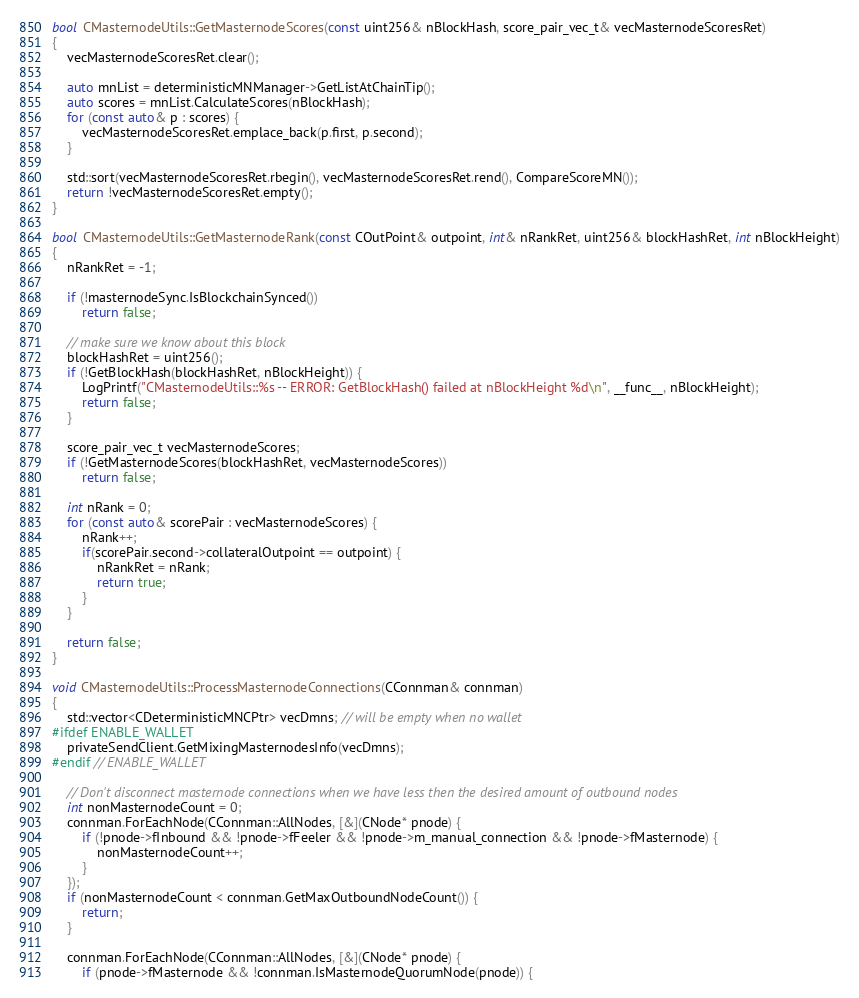Convert code to text. <code><loc_0><loc_0><loc_500><loc_500><_C++_>
bool CMasternodeUtils::GetMasternodeScores(const uint256& nBlockHash, score_pair_vec_t& vecMasternodeScoresRet)
{
    vecMasternodeScoresRet.clear();

    auto mnList = deterministicMNManager->GetListAtChainTip();
    auto scores = mnList.CalculateScores(nBlockHash);
    for (const auto& p : scores) {
        vecMasternodeScoresRet.emplace_back(p.first, p.second);
    }

    std::sort(vecMasternodeScoresRet.rbegin(), vecMasternodeScoresRet.rend(), CompareScoreMN());
    return !vecMasternodeScoresRet.empty();
}

bool CMasternodeUtils::GetMasternodeRank(const COutPoint& outpoint, int& nRankRet, uint256& blockHashRet, int nBlockHeight)
{
    nRankRet = -1;

    if (!masternodeSync.IsBlockchainSynced())
        return false;

    // make sure we know about this block
    blockHashRet = uint256();
    if (!GetBlockHash(blockHashRet, nBlockHeight)) {
        LogPrintf("CMasternodeUtils::%s -- ERROR: GetBlockHash() failed at nBlockHeight %d\n", __func__, nBlockHeight);
        return false;
    }

    score_pair_vec_t vecMasternodeScores;
    if (!GetMasternodeScores(blockHashRet, vecMasternodeScores))
        return false;

    int nRank = 0;
    for (const auto& scorePair : vecMasternodeScores) {
        nRank++;
        if(scorePair.second->collateralOutpoint == outpoint) {
            nRankRet = nRank;
            return true;
        }
    }

    return false;
}

void CMasternodeUtils::ProcessMasternodeConnections(CConnman& connman)
{
    std::vector<CDeterministicMNCPtr> vecDmns; // will be empty when no wallet
#ifdef ENABLE_WALLET
    privateSendClient.GetMixingMasternodesInfo(vecDmns);
#endif // ENABLE_WALLET

    // Don't disconnect masternode connections when we have less then the desired amount of outbound nodes
    int nonMasternodeCount = 0;
    connman.ForEachNode(CConnman::AllNodes, [&](CNode* pnode) {
        if (!pnode->fInbound && !pnode->fFeeler && !pnode->m_manual_connection && !pnode->fMasternode) {
            nonMasternodeCount++;
        }
    });
    if (nonMasternodeCount < connman.GetMaxOutboundNodeCount()) {
        return;
    }

    connman.ForEachNode(CConnman::AllNodes, [&](CNode* pnode) {
        if (pnode->fMasternode && !connman.IsMasternodeQuorumNode(pnode)) {</code> 